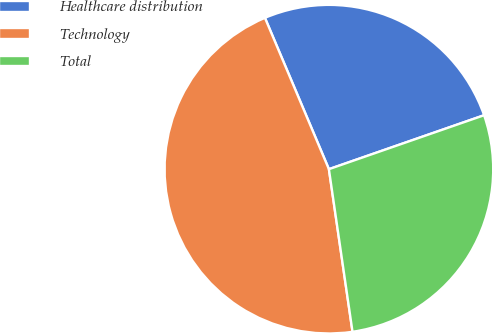Convert chart to OTSL. <chart><loc_0><loc_0><loc_500><loc_500><pie_chart><fcel>Healthcare distribution<fcel>Technology<fcel>Total<nl><fcel>26.04%<fcel>45.93%<fcel>28.03%<nl></chart> 